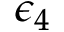Convert formula to latex. <formula><loc_0><loc_0><loc_500><loc_500>\epsilon _ { 4 }</formula> 